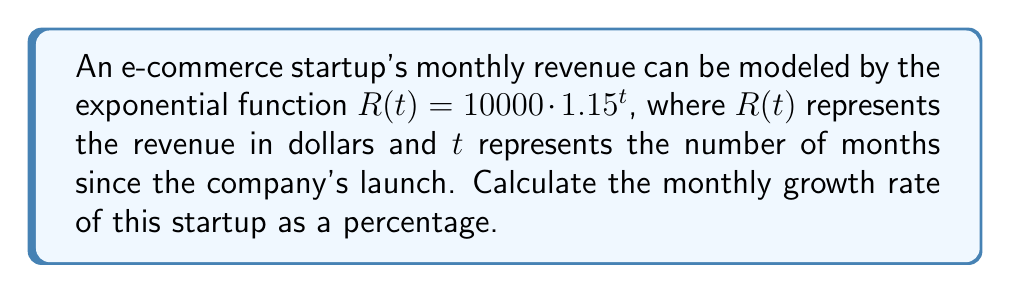Teach me how to tackle this problem. To find the monthly growth rate, we need to analyze the exponential function:

1. The general form of an exponential function is $f(t) = a \cdot b^t$, where $b$ represents the growth factor.

2. In our case, $R(t) = 10000 \cdot 1.15^t$, so the growth factor is 1.15.

3. The growth factor represents how much the function increases each month. To convert this to a percentage increase, we subtract 1 from the growth factor and multiply by 100:

   Growth rate = $(1.15 - 1) \times 100\%$
                = $0.15 \times 100\%$
                = $15\%$

4. Therefore, the monthly growth rate is 15%.

This means that each month, the startup's revenue increases by 15% compared to the previous month.
Answer: 15% 